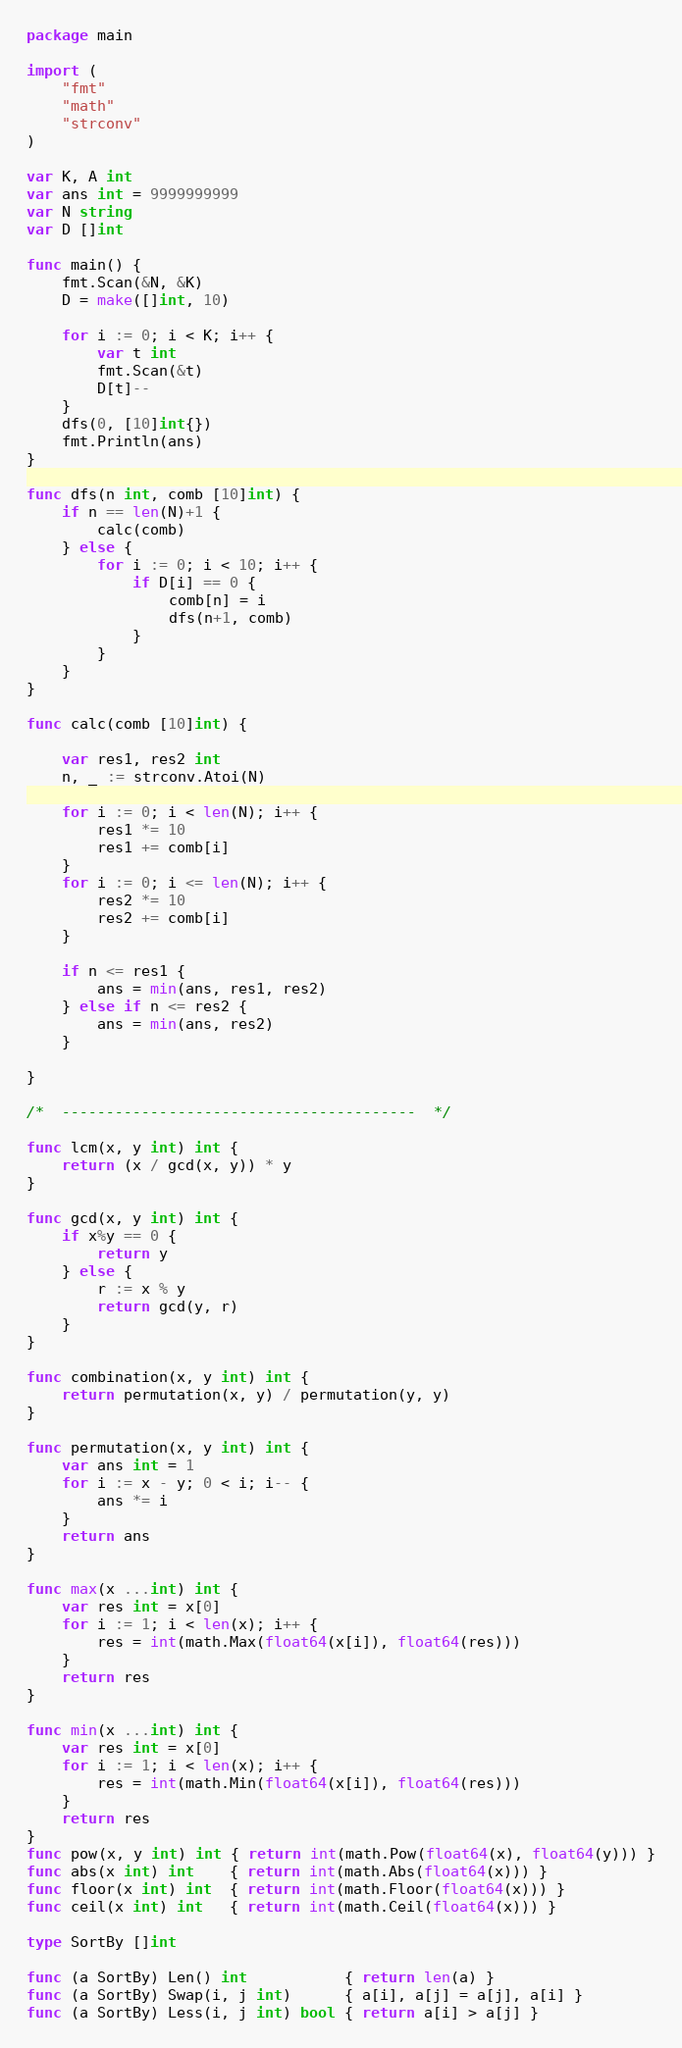Convert code to text. <code><loc_0><loc_0><loc_500><loc_500><_Go_>package main

import (
	"fmt"
	"math"
	"strconv"
)

var K, A int
var ans int = 9999999999
var N string
var D []int

func main() {
	fmt.Scan(&N, &K)
	D = make([]int, 10)

	for i := 0; i < K; i++ {
		var t int
		fmt.Scan(&t)
		D[t]--
	}
	dfs(0, [10]int{})
	fmt.Println(ans)
}

func dfs(n int, comb [10]int) {
	if n == len(N)+1 {
		calc(comb)
	} else {
		for i := 0; i < 10; i++ {
			if D[i] == 0 {
				comb[n] = i
				dfs(n+1, comb)
			}
		}
	}
}

func calc(comb [10]int) {

	var res1, res2 int
	n, _ := strconv.Atoi(N)

	for i := 0; i < len(N); i++ {
		res1 *= 10
		res1 += comb[i]
	}
	for i := 0; i <= len(N); i++ {
		res2 *= 10
		res2 += comb[i]
	}

	if n <= res1 {
		ans = min(ans, res1, res2)
	} else if n <= res2 {
		ans = min(ans, res2)
	}

}

/*  ----------------------------------------  */

func lcm(x, y int) int {
	return (x / gcd(x, y)) * y
}

func gcd(x, y int) int {
	if x%y == 0 {
		return y
	} else {
		r := x % y
		return gcd(y, r)
	}
}

func combination(x, y int) int {
	return permutation(x, y) / permutation(y, y)
}

func permutation(x, y int) int {
	var ans int = 1
	for i := x - y; 0 < i; i-- {
		ans *= i
	}
	return ans
}

func max(x ...int) int {
	var res int = x[0]
	for i := 1; i < len(x); i++ {
		res = int(math.Max(float64(x[i]), float64(res)))
	}
	return res
}

func min(x ...int) int {
	var res int = x[0]
	for i := 1; i < len(x); i++ {
		res = int(math.Min(float64(x[i]), float64(res)))
	}
	return res
}
func pow(x, y int) int { return int(math.Pow(float64(x), float64(y))) }
func abs(x int) int    { return int(math.Abs(float64(x))) }
func floor(x int) int  { return int(math.Floor(float64(x))) }
func ceil(x int) int   { return int(math.Ceil(float64(x))) }

type SortBy []int

func (a SortBy) Len() int           { return len(a) }
func (a SortBy) Swap(i, j int)      { a[i], a[j] = a[j], a[i] }
func (a SortBy) Less(i, j int) bool { return a[i] > a[j] }
</code> 